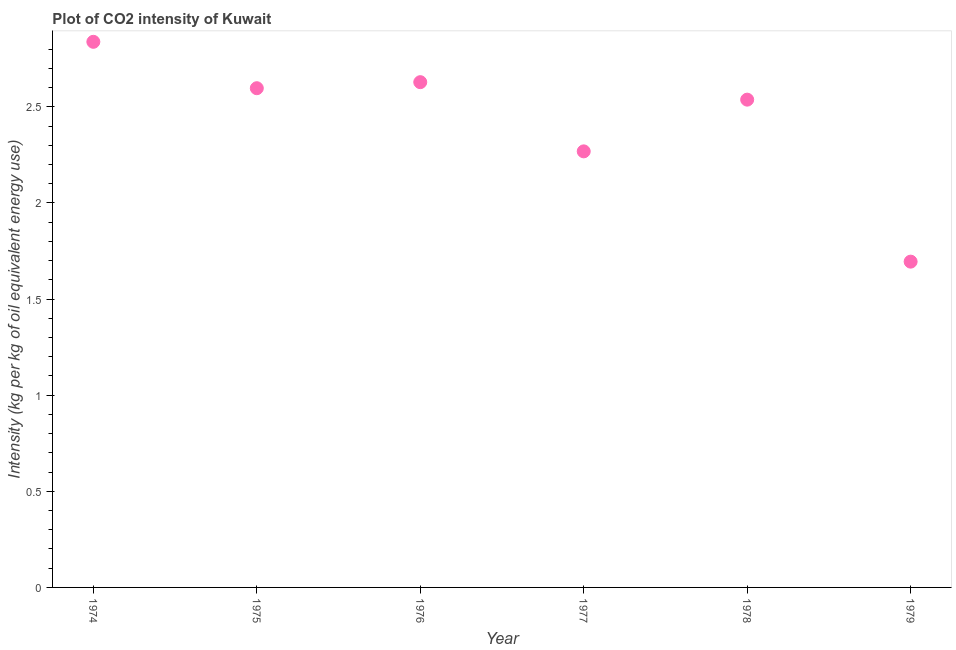What is the co2 intensity in 1976?
Your answer should be very brief. 2.63. Across all years, what is the maximum co2 intensity?
Your response must be concise. 2.84. Across all years, what is the minimum co2 intensity?
Your answer should be very brief. 1.69. In which year was the co2 intensity maximum?
Provide a short and direct response. 1974. In which year was the co2 intensity minimum?
Give a very brief answer. 1979. What is the sum of the co2 intensity?
Provide a short and direct response. 14.56. What is the difference between the co2 intensity in 1977 and 1979?
Provide a short and direct response. 0.57. What is the average co2 intensity per year?
Ensure brevity in your answer.  2.43. What is the median co2 intensity?
Ensure brevity in your answer.  2.57. In how many years, is the co2 intensity greater than 2.2 kg?
Provide a succinct answer. 5. Do a majority of the years between 1975 and 1977 (inclusive) have co2 intensity greater than 0.9 kg?
Give a very brief answer. Yes. What is the ratio of the co2 intensity in 1975 to that in 1977?
Provide a short and direct response. 1.14. Is the co2 intensity in 1977 less than that in 1979?
Provide a succinct answer. No. Is the difference between the co2 intensity in 1974 and 1976 greater than the difference between any two years?
Ensure brevity in your answer.  No. What is the difference between the highest and the second highest co2 intensity?
Keep it short and to the point. 0.21. Is the sum of the co2 intensity in 1976 and 1978 greater than the maximum co2 intensity across all years?
Your answer should be very brief. Yes. What is the difference between the highest and the lowest co2 intensity?
Your answer should be compact. 1.14. In how many years, is the co2 intensity greater than the average co2 intensity taken over all years?
Provide a succinct answer. 4. How many dotlines are there?
Give a very brief answer. 1. How many years are there in the graph?
Provide a short and direct response. 6. Does the graph contain any zero values?
Offer a very short reply. No. Does the graph contain grids?
Keep it short and to the point. No. What is the title of the graph?
Provide a short and direct response. Plot of CO2 intensity of Kuwait. What is the label or title of the X-axis?
Your answer should be compact. Year. What is the label or title of the Y-axis?
Your answer should be very brief. Intensity (kg per kg of oil equivalent energy use). What is the Intensity (kg per kg of oil equivalent energy use) in 1974?
Give a very brief answer. 2.84. What is the Intensity (kg per kg of oil equivalent energy use) in 1975?
Give a very brief answer. 2.6. What is the Intensity (kg per kg of oil equivalent energy use) in 1976?
Keep it short and to the point. 2.63. What is the Intensity (kg per kg of oil equivalent energy use) in 1977?
Offer a very short reply. 2.27. What is the Intensity (kg per kg of oil equivalent energy use) in 1978?
Ensure brevity in your answer.  2.54. What is the Intensity (kg per kg of oil equivalent energy use) in 1979?
Keep it short and to the point. 1.69. What is the difference between the Intensity (kg per kg of oil equivalent energy use) in 1974 and 1975?
Your answer should be very brief. 0.24. What is the difference between the Intensity (kg per kg of oil equivalent energy use) in 1974 and 1976?
Provide a succinct answer. 0.21. What is the difference between the Intensity (kg per kg of oil equivalent energy use) in 1974 and 1977?
Provide a short and direct response. 0.57. What is the difference between the Intensity (kg per kg of oil equivalent energy use) in 1974 and 1978?
Your answer should be very brief. 0.3. What is the difference between the Intensity (kg per kg of oil equivalent energy use) in 1974 and 1979?
Your answer should be very brief. 1.14. What is the difference between the Intensity (kg per kg of oil equivalent energy use) in 1975 and 1976?
Ensure brevity in your answer.  -0.03. What is the difference between the Intensity (kg per kg of oil equivalent energy use) in 1975 and 1977?
Your answer should be compact. 0.33. What is the difference between the Intensity (kg per kg of oil equivalent energy use) in 1975 and 1978?
Give a very brief answer. 0.06. What is the difference between the Intensity (kg per kg of oil equivalent energy use) in 1975 and 1979?
Offer a very short reply. 0.9. What is the difference between the Intensity (kg per kg of oil equivalent energy use) in 1976 and 1977?
Offer a very short reply. 0.36. What is the difference between the Intensity (kg per kg of oil equivalent energy use) in 1976 and 1978?
Provide a short and direct response. 0.09. What is the difference between the Intensity (kg per kg of oil equivalent energy use) in 1976 and 1979?
Offer a terse response. 0.93. What is the difference between the Intensity (kg per kg of oil equivalent energy use) in 1977 and 1978?
Offer a very short reply. -0.27. What is the difference between the Intensity (kg per kg of oil equivalent energy use) in 1977 and 1979?
Make the answer very short. 0.57. What is the difference between the Intensity (kg per kg of oil equivalent energy use) in 1978 and 1979?
Make the answer very short. 0.84. What is the ratio of the Intensity (kg per kg of oil equivalent energy use) in 1974 to that in 1975?
Make the answer very short. 1.09. What is the ratio of the Intensity (kg per kg of oil equivalent energy use) in 1974 to that in 1976?
Provide a short and direct response. 1.08. What is the ratio of the Intensity (kg per kg of oil equivalent energy use) in 1974 to that in 1977?
Your answer should be compact. 1.25. What is the ratio of the Intensity (kg per kg of oil equivalent energy use) in 1974 to that in 1978?
Give a very brief answer. 1.12. What is the ratio of the Intensity (kg per kg of oil equivalent energy use) in 1974 to that in 1979?
Keep it short and to the point. 1.68. What is the ratio of the Intensity (kg per kg of oil equivalent energy use) in 1975 to that in 1977?
Give a very brief answer. 1.15. What is the ratio of the Intensity (kg per kg of oil equivalent energy use) in 1975 to that in 1978?
Your answer should be very brief. 1.02. What is the ratio of the Intensity (kg per kg of oil equivalent energy use) in 1975 to that in 1979?
Keep it short and to the point. 1.53. What is the ratio of the Intensity (kg per kg of oil equivalent energy use) in 1976 to that in 1977?
Offer a very short reply. 1.16. What is the ratio of the Intensity (kg per kg of oil equivalent energy use) in 1976 to that in 1978?
Give a very brief answer. 1.04. What is the ratio of the Intensity (kg per kg of oil equivalent energy use) in 1976 to that in 1979?
Keep it short and to the point. 1.55. What is the ratio of the Intensity (kg per kg of oil equivalent energy use) in 1977 to that in 1978?
Offer a terse response. 0.89. What is the ratio of the Intensity (kg per kg of oil equivalent energy use) in 1977 to that in 1979?
Provide a short and direct response. 1.34. What is the ratio of the Intensity (kg per kg of oil equivalent energy use) in 1978 to that in 1979?
Provide a succinct answer. 1.5. 